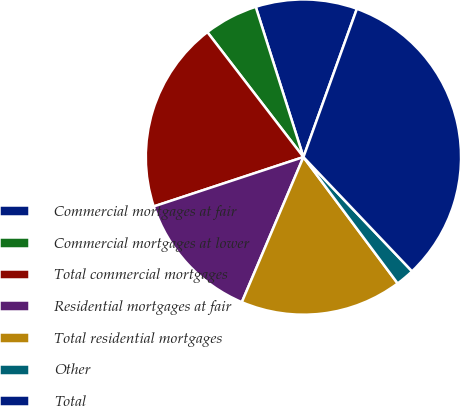Convert chart. <chart><loc_0><loc_0><loc_500><loc_500><pie_chart><fcel>Commercial mortgages at fair<fcel>Commercial mortgages at lower<fcel>Total commercial mortgages<fcel>Residential mortgages at fair<fcel>Total residential mortgages<fcel>Other<fcel>Total<nl><fcel>10.4%<fcel>5.54%<fcel>19.64%<fcel>13.54%<fcel>16.59%<fcel>1.9%<fcel>32.4%<nl></chart> 